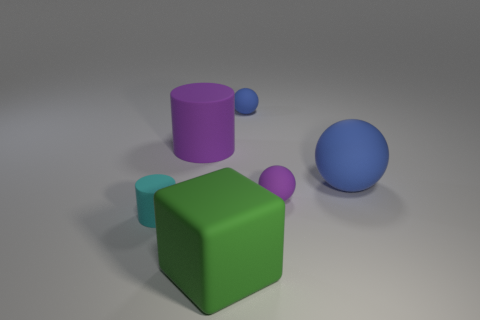Add 1 matte cylinders. How many objects exist? 7 Subtract all blocks. How many objects are left? 5 Add 3 rubber cubes. How many rubber cubes are left? 4 Add 2 small brown metal balls. How many small brown metal balls exist? 2 Subtract 0 brown balls. How many objects are left? 6 Subtract all big matte objects. Subtract all rubber spheres. How many objects are left? 0 